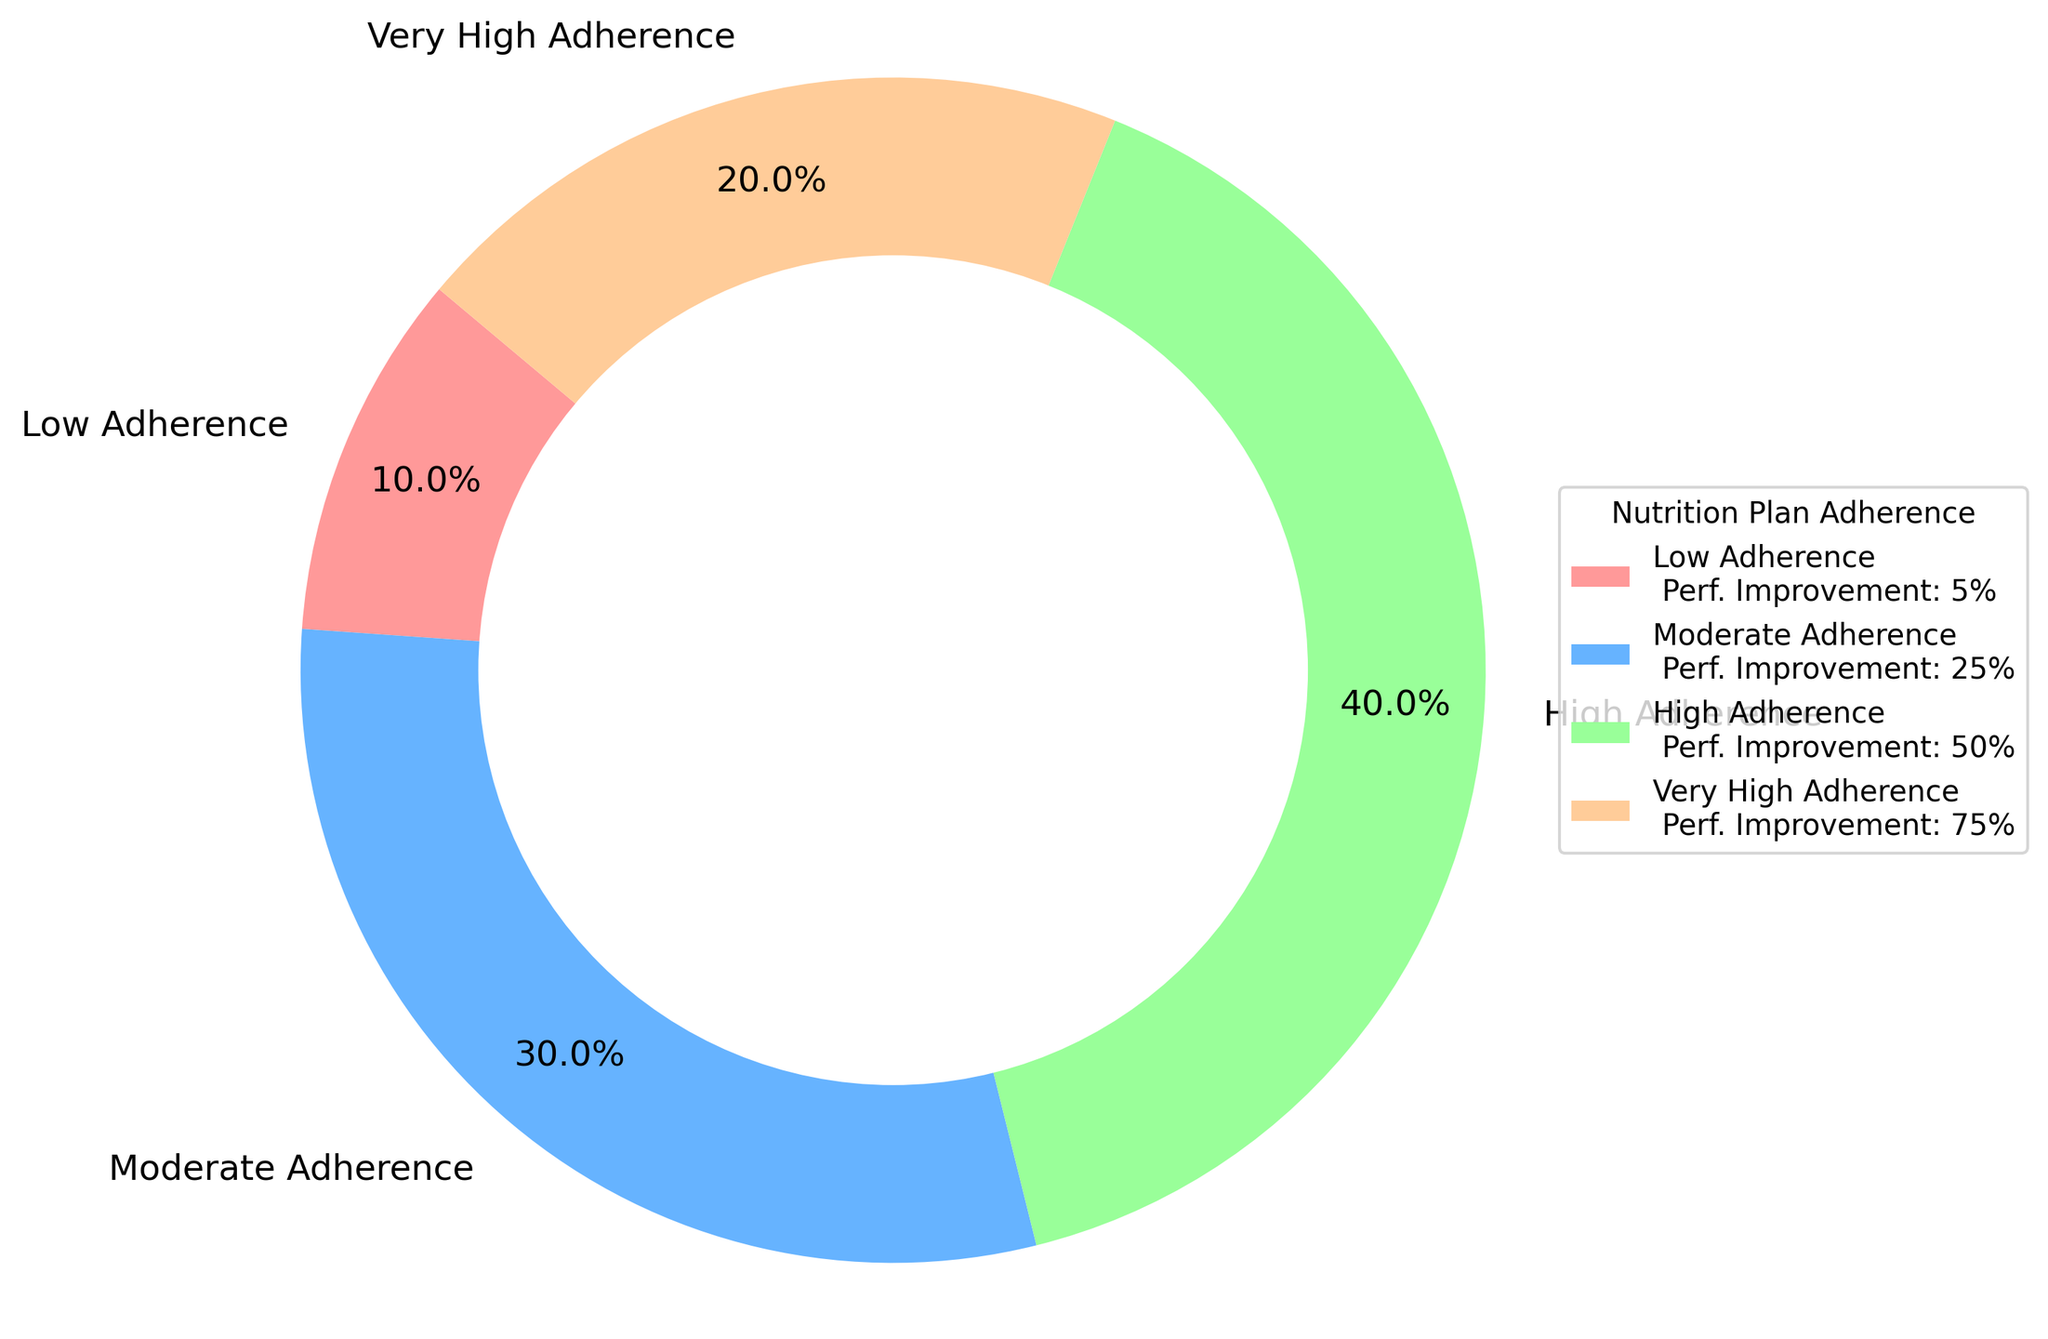Which category has the highest adherence? According to the pie chart, the 'High Adherence' category occupies the largest portion of the chart.
Answer: High Adherence Which category contributes most to performance improvement? The legend shows that the 'Very High Adherence' category has a 75% performance improvement, which is the highest in the chart.
Answer: Very High Adherence What is the total adherence percentage for 'Low Adherence' and 'Moderate Adherence' combined? The adherence percentages for 'Low Adherence' and 'Moderate Adherence' are 10% and 30%, respectively. Summing them up gives 10% + 30% = 40%.
Answer: 40% How does the performance improvement percentage for 'High Adherence' compare to 'Moderate Adherence'? The legend indicates that 'High Adherence' has a 50% performance improvement, while 'Moderate Adherence' has a 25% performance improvement. Therefore, 'High Adherence' has a higher performance improvement.
Answer: High Adherence has a higher performance improvement What is the average adherence percentage across all categories? To find the average, sum all adherence percentages and divide by the number of categories: (10% + 30% + 40% + 20%) / 4 = 25%.
Answer: 25% Which segment on the chart is represented by a red color? The red color represents the 'Low Adherence' category.
Answer: Low Adherence How much more is the performance improvement for 'Very High Adherence' compared to 'High Adherence'? The performance improvement for 'Very High Adherence' is 75%, and for 'High Adherence' is 50%. The difference is 75% - 50% = 25%.
Answer: 25% Rank the categories by adherence percentage from highest to lowest. The adherence percentages are: High Adherence (40%), Moderate Adherence (30%), Very High Adherence (20%), Low Adherence (10%). So the ranking is: High Adherence, Moderate Adherence, Very High Adherence, Low Adherence.
Answer: High Adherence, Moderate Adherence, Very High Adherence, Low Adherence 